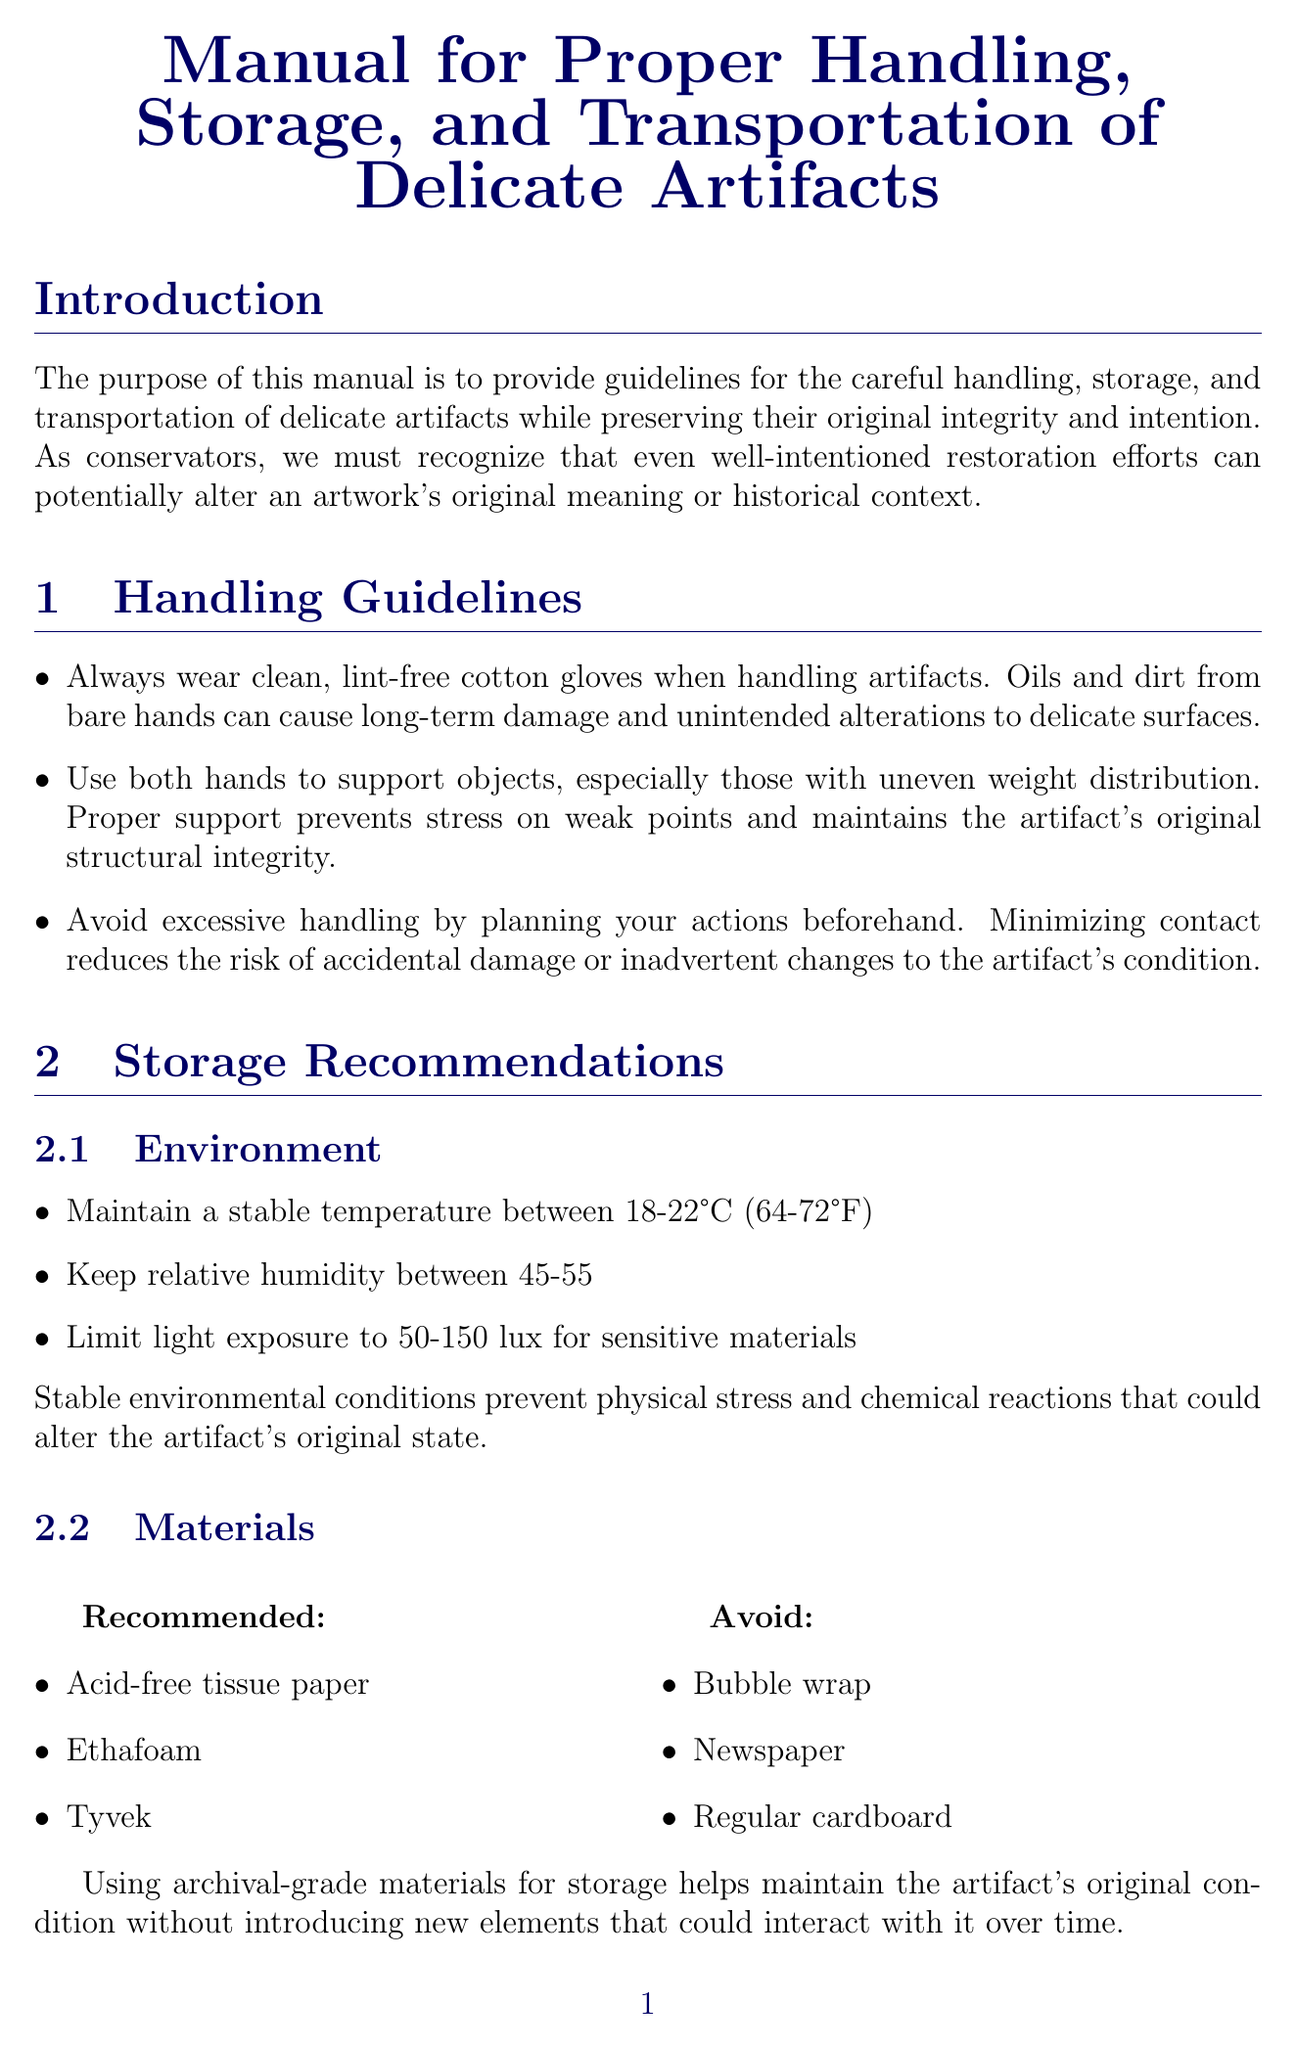what is the purpose of the manual? The purpose of the manual is outlined in the introduction as providing guidelines for careful handling, storage, and transportation of delicate artifacts while preserving their original integrity and intention.
Answer: guidelines for careful handling, storage, and transportation what is the recommended temperature range for storage? The recommended temperature range for storage is found in the storage recommendations section under the environment category.
Answer: 18-22°C (64-72°F) what materials should be avoided for storage? The materials to avoid for storage are listed separately in the storage recommendations section, providing specific items to avoid.
Answer: Bubble wrap, Newspaper, Regular cardboard how should unframed canvases be transported? The special considerations section for paintings specifies how unframed canvases should be handled during transportation.
Answer: Transport unframed canvases upright, never flat what steps are included in the emergency response plan? The response plan details specific steps to take when addressing potential threats to artifact integrity and is outlined in the emergency preparedness section.
Answer: Immediate documentation of affected artifacts, Controlled relocation to stable environments, Consultation with specialists before attempting any interventions how frequently should staff education occur? The frequency of staff education is indicated in the training and awareness section, highlighting the required schedule for training sessions.
Answer: Annual refresher courses what type of documentation is recommended before any movement? The manual mentions detailed documentation practices in the documentation and monitoring section, specifying what is necessary before movement.
Answer: Detailed written condition reports how can understanding material sensitivities help conservators? This falls under reasoning as understanding material sensitivities is crucial for preventing unintended damage, which aligns with the manual's emphasis on avoiding alterations.
Answer: Preventing unintended damage 